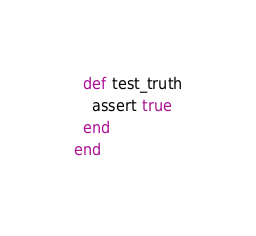<code> <loc_0><loc_0><loc_500><loc_500><_Ruby_>  def test_truth
    assert true
  end
end
</code> 